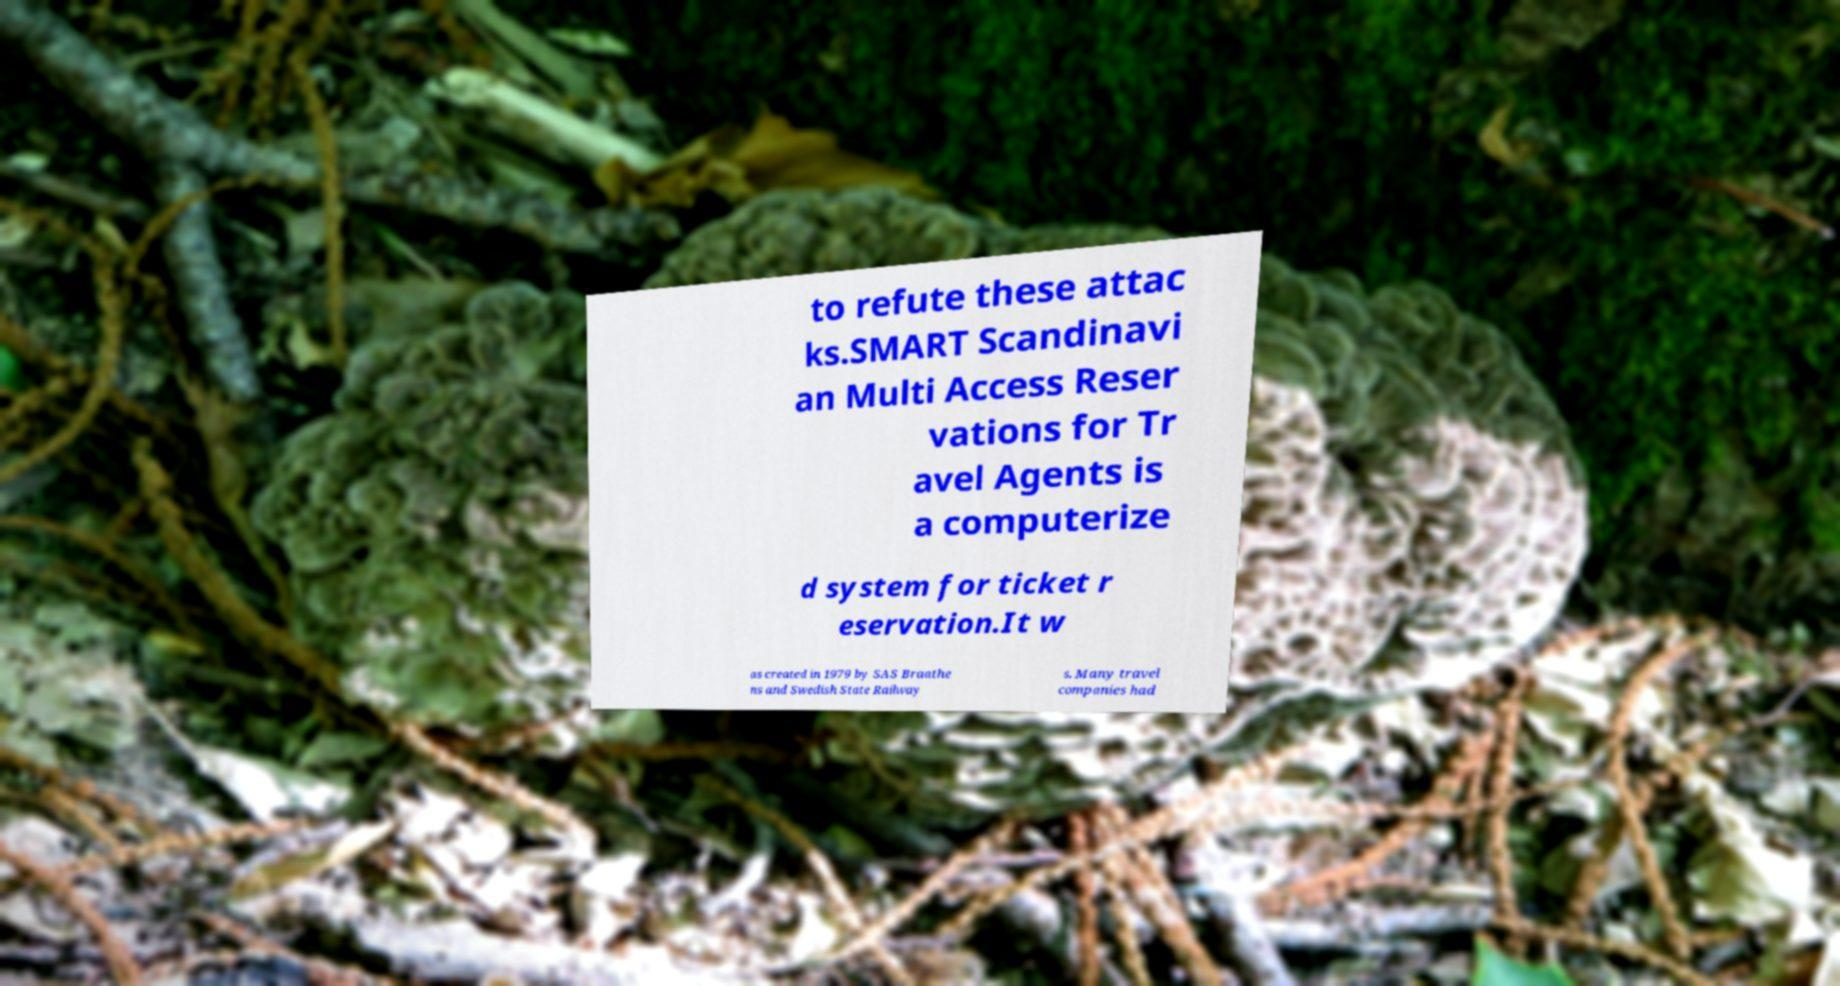What messages or text are displayed in this image? I need them in a readable, typed format. to refute these attac ks.SMART Scandinavi an Multi Access Reser vations for Tr avel Agents is a computerize d system for ticket r eservation.It w as created in 1979 by SAS Braathe ns and Swedish State Railway s. Many travel companies had 